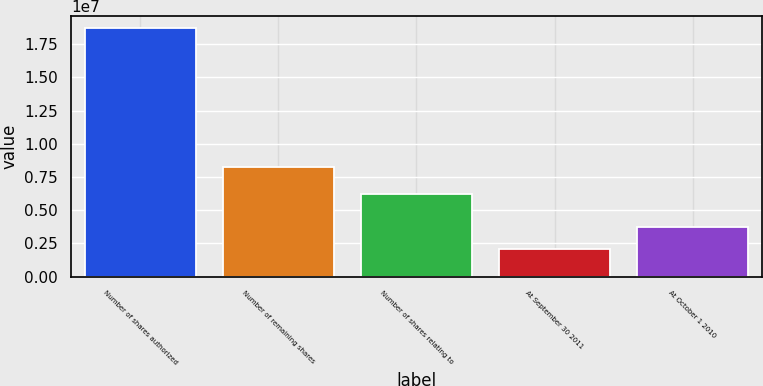Convert chart to OTSL. <chart><loc_0><loc_0><loc_500><loc_500><bar_chart><fcel>Number of shares authorized<fcel>Number of remaining shares<fcel>Number of shares relating to<fcel>At September 30 2011<fcel>At October 1 2010<nl><fcel>1.87e+07<fcel>8.25574e+06<fcel>6.20564e+06<fcel>2.05011e+06<fcel>3.7151e+06<nl></chart> 